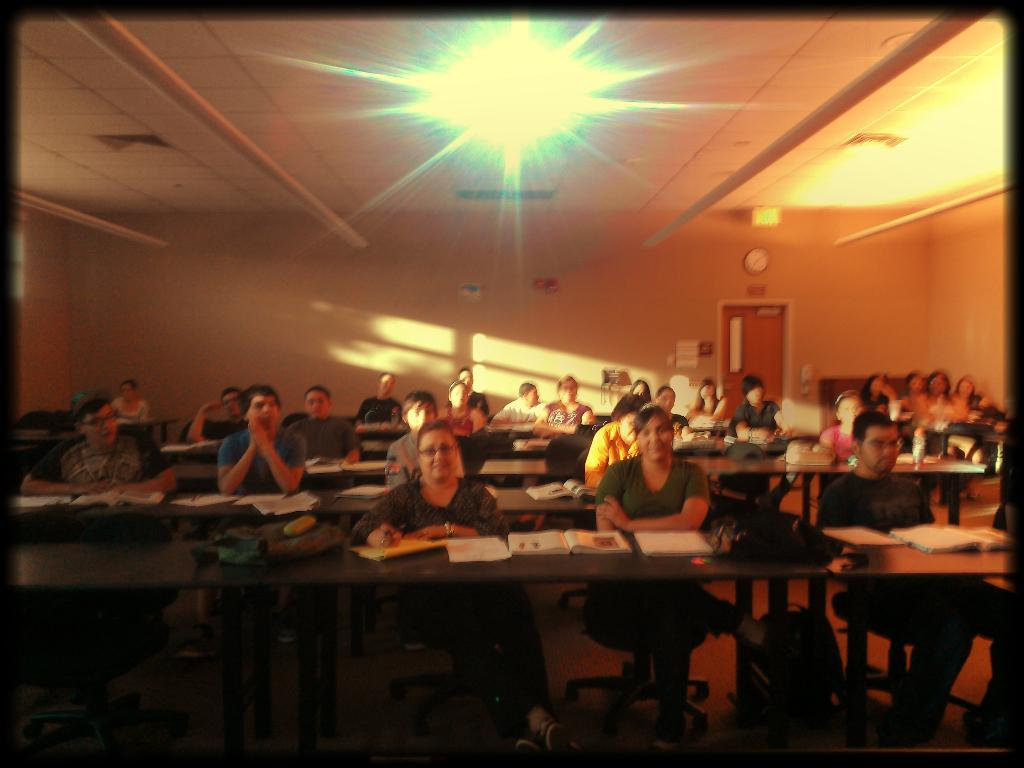How many people are in the image? There is a group of people in the image. What are the people doing in the image? The people are sitting on chairs. What is on the tables in front of the chairs? There are books and bags on the tables. What can be seen in the background of the image? There is a door, a clock, a wall, and lights in the background of the image. What type of pet is sitting on the bed in the image? There is no bed or pet present in the image. How does the clock burn in the image? The clock does not burn in the image; it is simply a clock hanging on the wall in the background. 